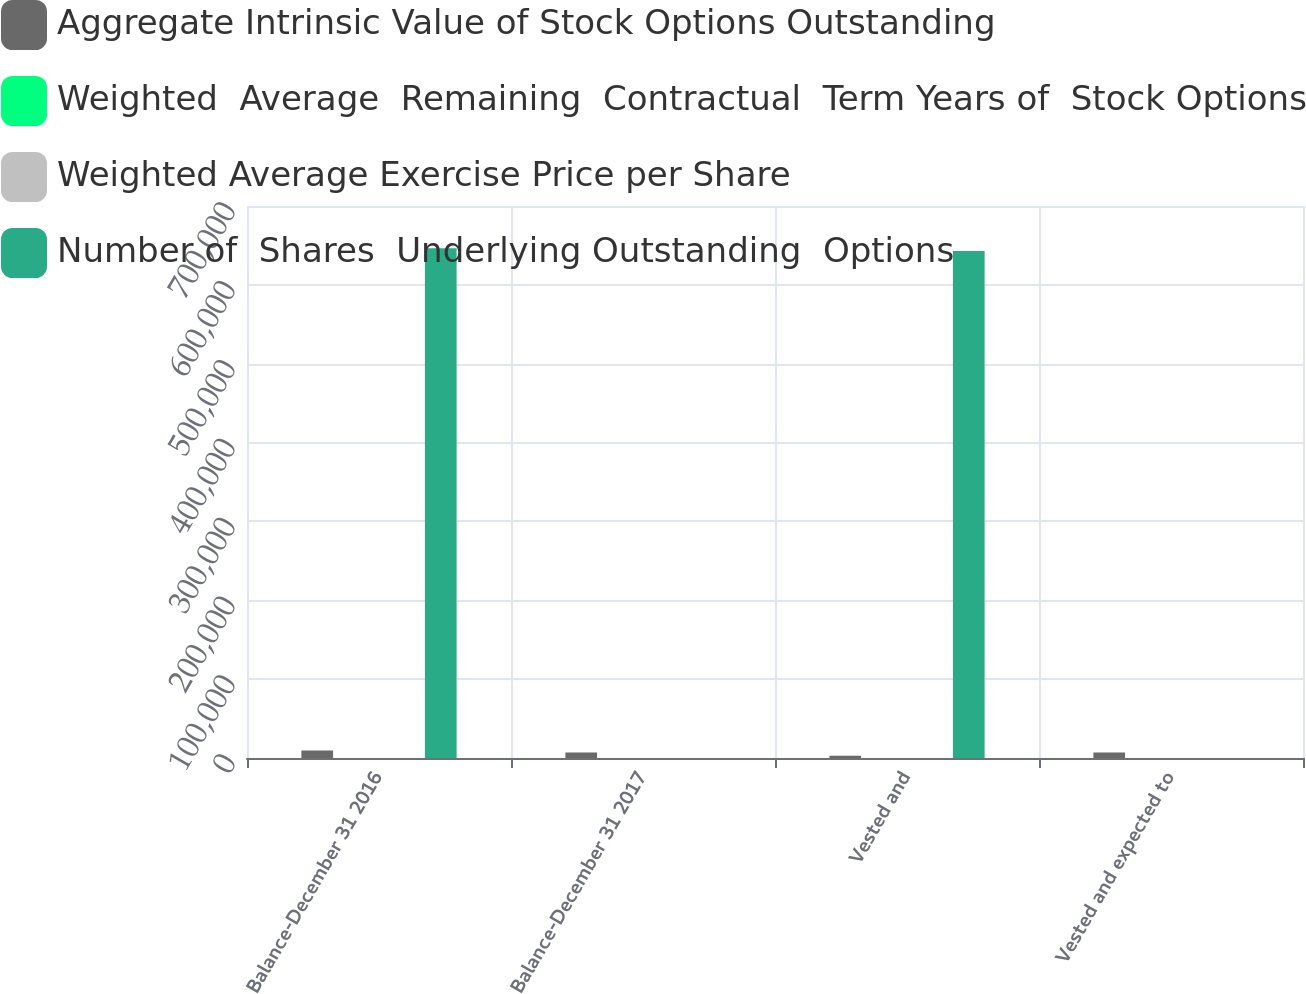Convert chart. <chart><loc_0><loc_0><loc_500><loc_500><stacked_bar_chart><ecel><fcel>Balance-December 31 2016<fcel>Balance-December 31 2017<fcel>Vested and<fcel>Vested and expected to<nl><fcel>Aggregate Intrinsic Value of Stock Options Outstanding<fcel>9509<fcel>7024<fcel>2992<fcel>7024<nl><fcel>Weighted  Average  Remaining  Contractual  Term Years of  Stock Options<fcel>28.79<fcel>33.05<fcel>20.7<fcel>33.05<nl><fcel>Weighted Average Exercise Price per Share<fcel>6.9<fcel>6.1<fcel>5.4<fcel>6.1<nl><fcel>Number of  Shares  Underlying Outstanding  Options<fcel>646394<fcel>33.05<fcel>643012<fcel>33.05<nl></chart> 